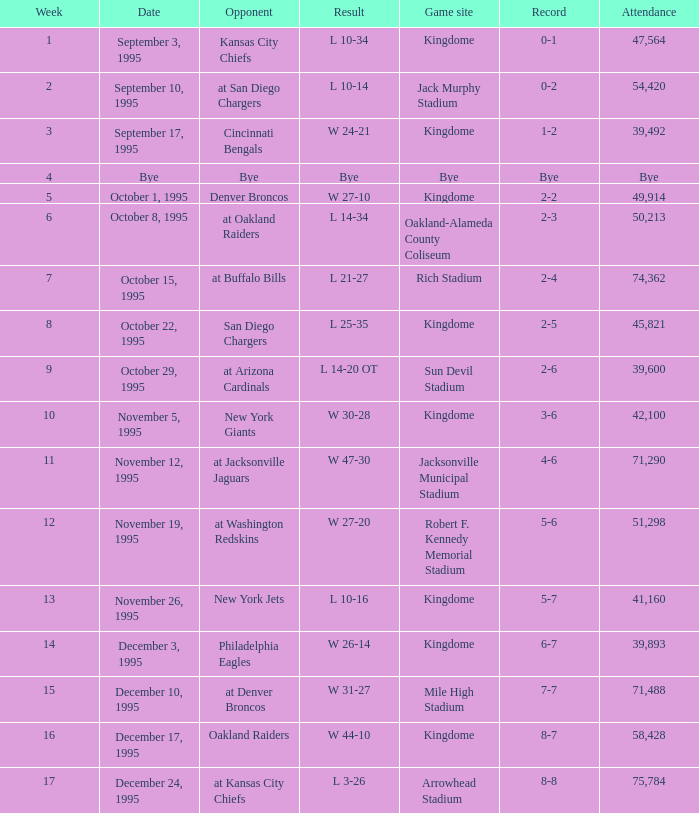Who was the opponent when the Seattle Seahawks had a record of 8-7? Oakland Raiders. 